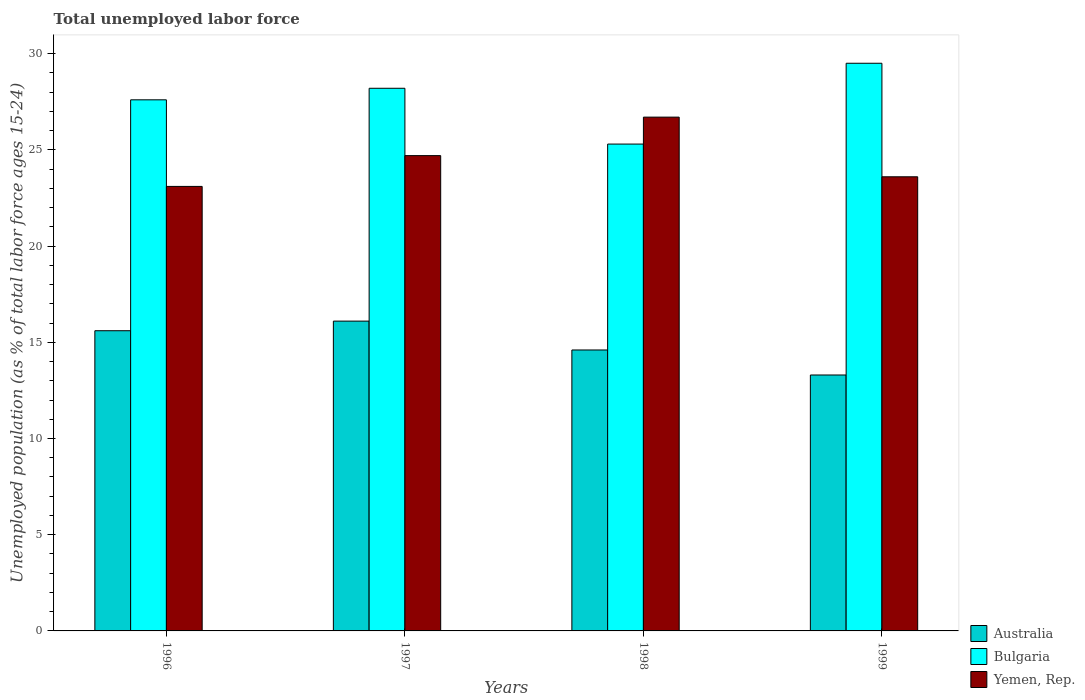How many different coloured bars are there?
Ensure brevity in your answer.  3. How many bars are there on the 4th tick from the left?
Offer a terse response. 3. In how many cases, is the number of bars for a given year not equal to the number of legend labels?
Provide a succinct answer. 0. What is the percentage of unemployed population in in Bulgaria in 1999?
Make the answer very short. 29.5. Across all years, what is the maximum percentage of unemployed population in in Yemen, Rep.?
Provide a short and direct response. 26.7. Across all years, what is the minimum percentage of unemployed population in in Yemen, Rep.?
Make the answer very short. 23.1. In which year was the percentage of unemployed population in in Yemen, Rep. maximum?
Your answer should be compact. 1998. In which year was the percentage of unemployed population in in Australia minimum?
Your answer should be compact. 1999. What is the total percentage of unemployed population in in Bulgaria in the graph?
Make the answer very short. 110.6. What is the difference between the percentage of unemployed population in in Australia in 1997 and that in 1998?
Keep it short and to the point. 1.5. What is the difference between the percentage of unemployed population in in Yemen, Rep. in 1998 and the percentage of unemployed population in in Bulgaria in 1999?
Your answer should be very brief. -2.8. What is the average percentage of unemployed population in in Yemen, Rep. per year?
Make the answer very short. 24.53. In the year 1996, what is the difference between the percentage of unemployed population in in Yemen, Rep. and percentage of unemployed population in in Bulgaria?
Make the answer very short. -4.5. What is the ratio of the percentage of unemployed population in in Australia in 1996 to that in 1998?
Ensure brevity in your answer.  1.07. Is the difference between the percentage of unemployed population in in Yemen, Rep. in 1996 and 1998 greater than the difference between the percentage of unemployed population in in Bulgaria in 1996 and 1998?
Offer a very short reply. No. What is the difference between the highest and the second highest percentage of unemployed population in in Bulgaria?
Provide a short and direct response. 1.3. What is the difference between the highest and the lowest percentage of unemployed population in in Bulgaria?
Provide a succinct answer. 4.2. Is the sum of the percentage of unemployed population in in Yemen, Rep. in 1996 and 1997 greater than the maximum percentage of unemployed population in in Australia across all years?
Your answer should be very brief. Yes. What does the 2nd bar from the left in 1998 represents?
Keep it short and to the point. Bulgaria. What does the 1st bar from the right in 1999 represents?
Give a very brief answer. Yemen, Rep. Are all the bars in the graph horizontal?
Offer a terse response. No. How many years are there in the graph?
Your response must be concise. 4. What is the difference between two consecutive major ticks on the Y-axis?
Offer a very short reply. 5. Are the values on the major ticks of Y-axis written in scientific E-notation?
Make the answer very short. No. Does the graph contain grids?
Keep it short and to the point. No. Where does the legend appear in the graph?
Offer a very short reply. Bottom right. How many legend labels are there?
Make the answer very short. 3. What is the title of the graph?
Give a very brief answer. Total unemployed labor force. What is the label or title of the Y-axis?
Your answer should be compact. Unemployed population (as % of total labor force ages 15-24). What is the Unemployed population (as % of total labor force ages 15-24) in Australia in 1996?
Make the answer very short. 15.6. What is the Unemployed population (as % of total labor force ages 15-24) of Bulgaria in 1996?
Keep it short and to the point. 27.6. What is the Unemployed population (as % of total labor force ages 15-24) in Yemen, Rep. in 1996?
Offer a terse response. 23.1. What is the Unemployed population (as % of total labor force ages 15-24) in Australia in 1997?
Provide a succinct answer. 16.1. What is the Unemployed population (as % of total labor force ages 15-24) in Bulgaria in 1997?
Offer a very short reply. 28.2. What is the Unemployed population (as % of total labor force ages 15-24) in Yemen, Rep. in 1997?
Keep it short and to the point. 24.7. What is the Unemployed population (as % of total labor force ages 15-24) in Australia in 1998?
Provide a succinct answer. 14.6. What is the Unemployed population (as % of total labor force ages 15-24) of Bulgaria in 1998?
Keep it short and to the point. 25.3. What is the Unemployed population (as % of total labor force ages 15-24) in Yemen, Rep. in 1998?
Ensure brevity in your answer.  26.7. What is the Unemployed population (as % of total labor force ages 15-24) in Australia in 1999?
Keep it short and to the point. 13.3. What is the Unemployed population (as % of total labor force ages 15-24) in Bulgaria in 1999?
Offer a terse response. 29.5. What is the Unemployed population (as % of total labor force ages 15-24) of Yemen, Rep. in 1999?
Your answer should be compact. 23.6. Across all years, what is the maximum Unemployed population (as % of total labor force ages 15-24) in Australia?
Give a very brief answer. 16.1. Across all years, what is the maximum Unemployed population (as % of total labor force ages 15-24) of Bulgaria?
Offer a very short reply. 29.5. Across all years, what is the maximum Unemployed population (as % of total labor force ages 15-24) of Yemen, Rep.?
Offer a terse response. 26.7. Across all years, what is the minimum Unemployed population (as % of total labor force ages 15-24) of Australia?
Keep it short and to the point. 13.3. Across all years, what is the minimum Unemployed population (as % of total labor force ages 15-24) in Bulgaria?
Provide a succinct answer. 25.3. Across all years, what is the minimum Unemployed population (as % of total labor force ages 15-24) in Yemen, Rep.?
Your answer should be compact. 23.1. What is the total Unemployed population (as % of total labor force ages 15-24) in Australia in the graph?
Your answer should be compact. 59.6. What is the total Unemployed population (as % of total labor force ages 15-24) in Bulgaria in the graph?
Make the answer very short. 110.6. What is the total Unemployed population (as % of total labor force ages 15-24) in Yemen, Rep. in the graph?
Offer a very short reply. 98.1. What is the difference between the Unemployed population (as % of total labor force ages 15-24) of Australia in 1996 and that in 1997?
Ensure brevity in your answer.  -0.5. What is the difference between the Unemployed population (as % of total labor force ages 15-24) in Bulgaria in 1996 and that in 1997?
Your answer should be compact. -0.6. What is the difference between the Unemployed population (as % of total labor force ages 15-24) of Yemen, Rep. in 1996 and that in 1997?
Make the answer very short. -1.6. What is the difference between the Unemployed population (as % of total labor force ages 15-24) of Australia in 1996 and that in 1998?
Your answer should be compact. 1. What is the difference between the Unemployed population (as % of total labor force ages 15-24) in Australia in 1996 and that in 1999?
Keep it short and to the point. 2.3. What is the difference between the Unemployed population (as % of total labor force ages 15-24) in Bulgaria in 1996 and that in 1999?
Provide a short and direct response. -1.9. What is the difference between the Unemployed population (as % of total labor force ages 15-24) of Yemen, Rep. in 1996 and that in 1999?
Your answer should be very brief. -0.5. What is the difference between the Unemployed population (as % of total labor force ages 15-24) in Australia in 1997 and that in 1998?
Provide a succinct answer. 1.5. What is the difference between the Unemployed population (as % of total labor force ages 15-24) in Australia in 1997 and that in 1999?
Ensure brevity in your answer.  2.8. What is the difference between the Unemployed population (as % of total labor force ages 15-24) of Australia in 1998 and that in 1999?
Keep it short and to the point. 1.3. What is the difference between the Unemployed population (as % of total labor force ages 15-24) of Yemen, Rep. in 1998 and that in 1999?
Offer a very short reply. 3.1. What is the difference between the Unemployed population (as % of total labor force ages 15-24) in Australia in 1996 and the Unemployed population (as % of total labor force ages 15-24) in Bulgaria in 1997?
Offer a terse response. -12.6. What is the difference between the Unemployed population (as % of total labor force ages 15-24) of Bulgaria in 1996 and the Unemployed population (as % of total labor force ages 15-24) of Yemen, Rep. in 1998?
Offer a terse response. 0.9. What is the difference between the Unemployed population (as % of total labor force ages 15-24) in Australia in 1996 and the Unemployed population (as % of total labor force ages 15-24) in Bulgaria in 1999?
Provide a short and direct response. -13.9. What is the difference between the Unemployed population (as % of total labor force ages 15-24) of Bulgaria in 1996 and the Unemployed population (as % of total labor force ages 15-24) of Yemen, Rep. in 1999?
Keep it short and to the point. 4. What is the difference between the Unemployed population (as % of total labor force ages 15-24) of Australia in 1997 and the Unemployed population (as % of total labor force ages 15-24) of Bulgaria in 1998?
Offer a very short reply. -9.2. What is the difference between the Unemployed population (as % of total labor force ages 15-24) in Bulgaria in 1997 and the Unemployed population (as % of total labor force ages 15-24) in Yemen, Rep. in 1998?
Ensure brevity in your answer.  1.5. What is the difference between the Unemployed population (as % of total labor force ages 15-24) in Australia in 1997 and the Unemployed population (as % of total labor force ages 15-24) in Bulgaria in 1999?
Ensure brevity in your answer.  -13.4. What is the difference between the Unemployed population (as % of total labor force ages 15-24) of Bulgaria in 1997 and the Unemployed population (as % of total labor force ages 15-24) of Yemen, Rep. in 1999?
Your answer should be compact. 4.6. What is the difference between the Unemployed population (as % of total labor force ages 15-24) of Australia in 1998 and the Unemployed population (as % of total labor force ages 15-24) of Bulgaria in 1999?
Provide a succinct answer. -14.9. What is the difference between the Unemployed population (as % of total labor force ages 15-24) in Bulgaria in 1998 and the Unemployed population (as % of total labor force ages 15-24) in Yemen, Rep. in 1999?
Your response must be concise. 1.7. What is the average Unemployed population (as % of total labor force ages 15-24) of Australia per year?
Provide a short and direct response. 14.9. What is the average Unemployed population (as % of total labor force ages 15-24) of Bulgaria per year?
Offer a terse response. 27.65. What is the average Unemployed population (as % of total labor force ages 15-24) of Yemen, Rep. per year?
Provide a succinct answer. 24.52. In the year 1996, what is the difference between the Unemployed population (as % of total labor force ages 15-24) in Australia and Unemployed population (as % of total labor force ages 15-24) in Yemen, Rep.?
Offer a terse response. -7.5. In the year 1996, what is the difference between the Unemployed population (as % of total labor force ages 15-24) in Bulgaria and Unemployed population (as % of total labor force ages 15-24) in Yemen, Rep.?
Provide a succinct answer. 4.5. In the year 1997, what is the difference between the Unemployed population (as % of total labor force ages 15-24) of Australia and Unemployed population (as % of total labor force ages 15-24) of Bulgaria?
Provide a short and direct response. -12.1. In the year 1997, what is the difference between the Unemployed population (as % of total labor force ages 15-24) in Australia and Unemployed population (as % of total labor force ages 15-24) in Yemen, Rep.?
Ensure brevity in your answer.  -8.6. In the year 1997, what is the difference between the Unemployed population (as % of total labor force ages 15-24) in Bulgaria and Unemployed population (as % of total labor force ages 15-24) in Yemen, Rep.?
Provide a succinct answer. 3.5. In the year 1998, what is the difference between the Unemployed population (as % of total labor force ages 15-24) in Australia and Unemployed population (as % of total labor force ages 15-24) in Yemen, Rep.?
Offer a terse response. -12.1. In the year 1998, what is the difference between the Unemployed population (as % of total labor force ages 15-24) of Bulgaria and Unemployed population (as % of total labor force ages 15-24) of Yemen, Rep.?
Offer a very short reply. -1.4. In the year 1999, what is the difference between the Unemployed population (as % of total labor force ages 15-24) of Australia and Unemployed population (as % of total labor force ages 15-24) of Bulgaria?
Ensure brevity in your answer.  -16.2. What is the ratio of the Unemployed population (as % of total labor force ages 15-24) in Australia in 1996 to that in 1997?
Your answer should be very brief. 0.97. What is the ratio of the Unemployed population (as % of total labor force ages 15-24) of Bulgaria in 1996 to that in 1997?
Offer a terse response. 0.98. What is the ratio of the Unemployed population (as % of total labor force ages 15-24) of Yemen, Rep. in 1996 to that in 1997?
Offer a very short reply. 0.94. What is the ratio of the Unemployed population (as % of total labor force ages 15-24) in Australia in 1996 to that in 1998?
Your answer should be compact. 1.07. What is the ratio of the Unemployed population (as % of total labor force ages 15-24) in Bulgaria in 1996 to that in 1998?
Keep it short and to the point. 1.09. What is the ratio of the Unemployed population (as % of total labor force ages 15-24) of Yemen, Rep. in 1996 to that in 1998?
Make the answer very short. 0.87. What is the ratio of the Unemployed population (as % of total labor force ages 15-24) of Australia in 1996 to that in 1999?
Your response must be concise. 1.17. What is the ratio of the Unemployed population (as % of total labor force ages 15-24) of Bulgaria in 1996 to that in 1999?
Offer a terse response. 0.94. What is the ratio of the Unemployed population (as % of total labor force ages 15-24) in Yemen, Rep. in 1996 to that in 1999?
Provide a short and direct response. 0.98. What is the ratio of the Unemployed population (as % of total labor force ages 15-24) of Australia in 1997 to that in 1998?
Give a very brief answer. 1.1. What is the ratio of the Unemployed population (as % of total labor force ages 15-24) of Bulgaria in 1997 to that in 1998?
Your response must be concise. 1.11. What is the ratio of the Unemployed population (as % of total labor force ages 15-24) in Yemen, Rep. in 1997 to that in 1998?
Give a very brief answer. 0.93. What is the ratio of the Unemployed population (as % of total labor force ages 15-24) in Australia in 1997 to that in 1999?
Offer a terse response. 1.21. What is the ratio of the Unemployed population (as % of total labor force ages 15-24) in Bulgaria in 1997 to that in 1999?
Ensure brevity in your answer.  0.96. What is the ratio of the Unemployed population (as % of total labor force ages 15-24) in Yemen, Rep. in 1997 to that in 1999?
Your answer should be very brief. 1.05. What is the ratio of the Unemployed population (as % of total labor force ages 15-24) in Australia in 1998 to that in 1999?
Provide a succinct answer. 1.1. What is the ratio of the Unemployed population (as % of total labor force ages 15-24) of Bulgaria in 1998 to that in 1999?
Provide a succinct answer. 0.86. What is the ratio of the Unemployed population (as % of total labor force ages 15-24) in Yemen, Rep. in 1998 to that in 1999?
Give a very brief answer. 1.13. What is the difference between the highest and the second highest Unemployed population (as % of total labor force ages 15-24) of Yemen, Rep.?
Offer a very short reply. 2. What is the difference between the highest and the lowest Unemployed population (as % of total labor force ages 15-24) in Australia?
Offer a very short reply. 2.8. What is the difference between the highest and the lowest Unemployed population (as % of total labor force ages 15-24) of Yemen, Rep.?
Offer a very short reply. 3.6. 